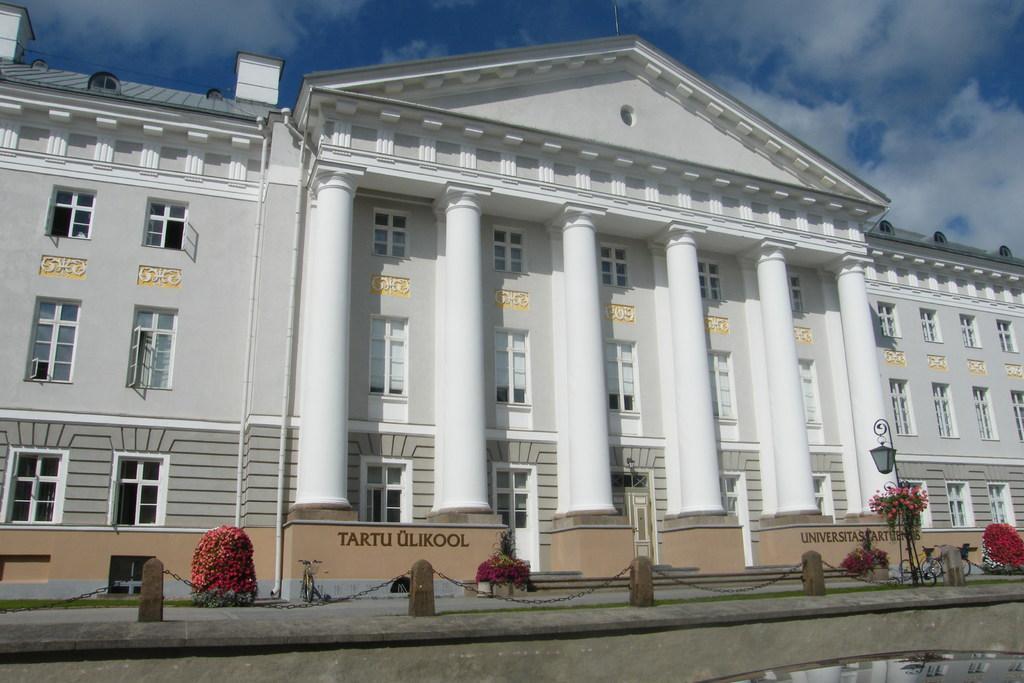Can you describe this image briefly? In this image in the center there is one building and at the bottom there are some plants, fence, flower pots and some lights. On the top of the image there is sky. 